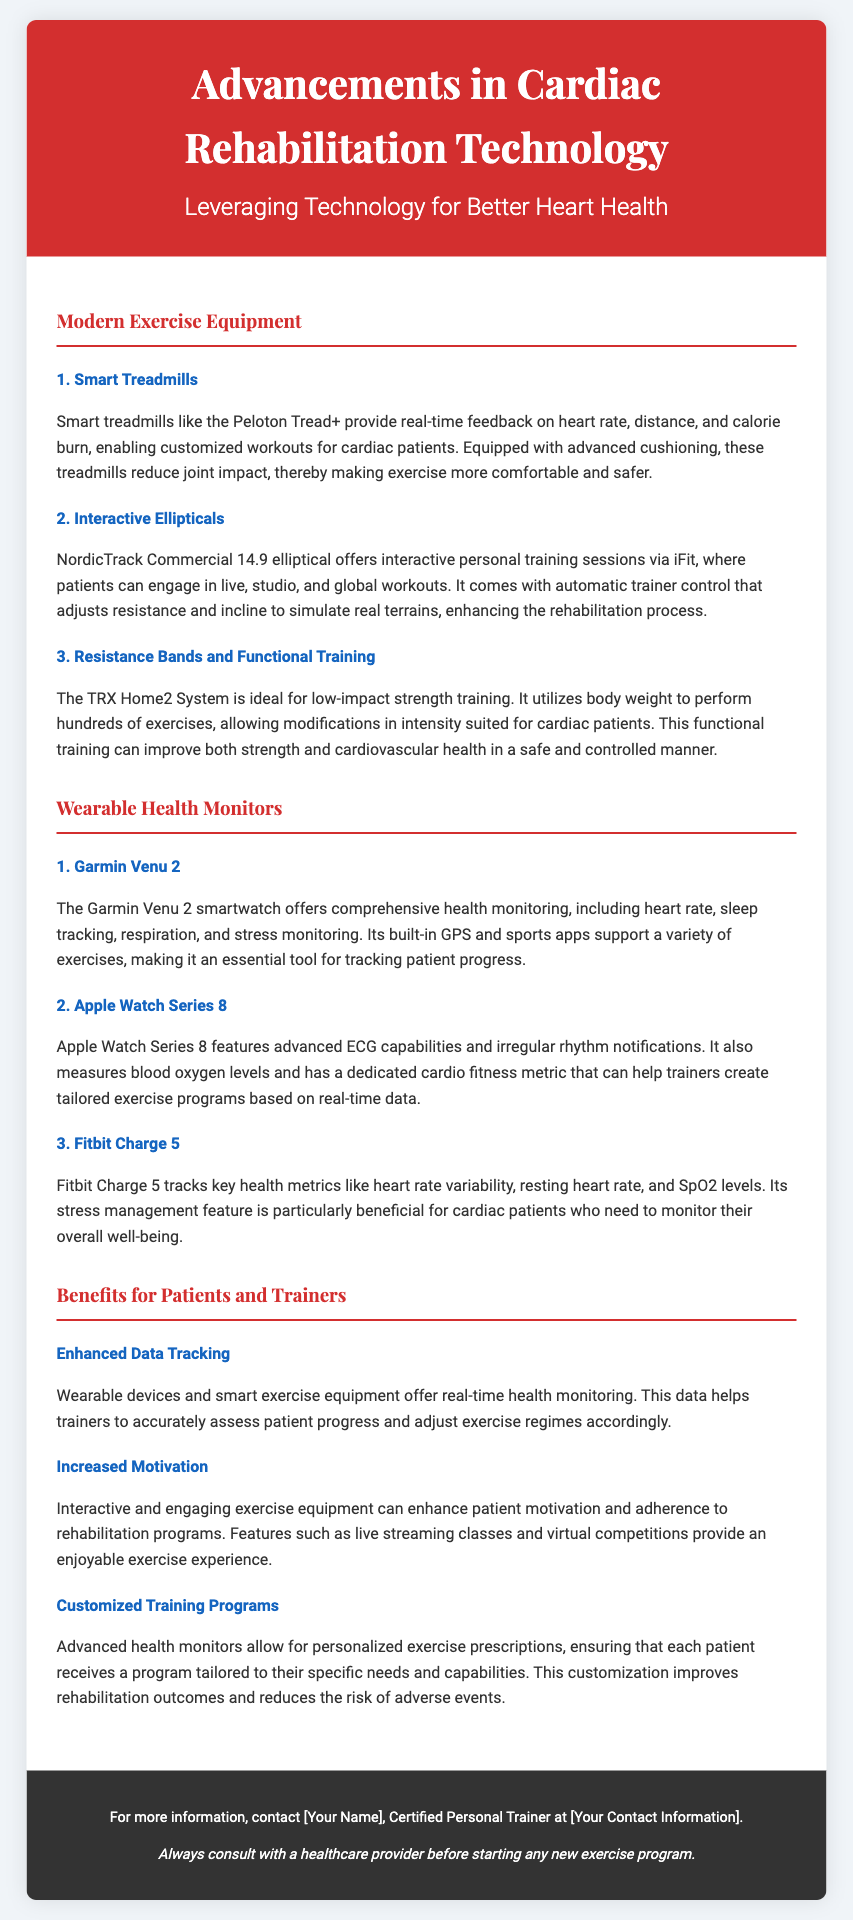what is the title of the Playbill? The title is prominently featured at the top of the document, indicating the main theme.
Answer: Advancements in Cardiac Rehabilitation Technology who is the author of the Playbill? The author is indicated in the footer section where contact information is typically provided.
Answer: [Your Name] which smartwatch is mentioned as having advanced ECG capabilities? This information is found under the section discussing wearable health monitors.
Answer: Apple Watch Series 8 what type of equipment does the TRX Home2 System focus on? The description of the TRX Home2 System highlights its training method, indicating its focus area.
Answer: Functional Training how does interactive exercise equipment enhance motivation? The benefits section explains how certain features can positively influence patient motivation.
Answer: Live streaming classes and virtual competitions what is a key feature of the Garmin Venu 2? The specific feature is listed as part of the comprehensive health monitoring benefits of the device.
Answer: Comprehensive health monitoring what is one benefit of wearable devices for trainers? This benefit is explicitly stated in the context of data and exercise adjustment for patient needs.
Answer: Enhanced Data Tracking how does the NordicTrack Commercial 14.9 elliptical support interactive training? The description outlines the mode of connection for training sessions that make it interactive.
Answer: iFit what is emphasized in the disclaimer section? The disclaimer serves as a precaution regarding new exercise programs, underlining the importance of professional advice.
Answer: Consult with a healthcare provider 